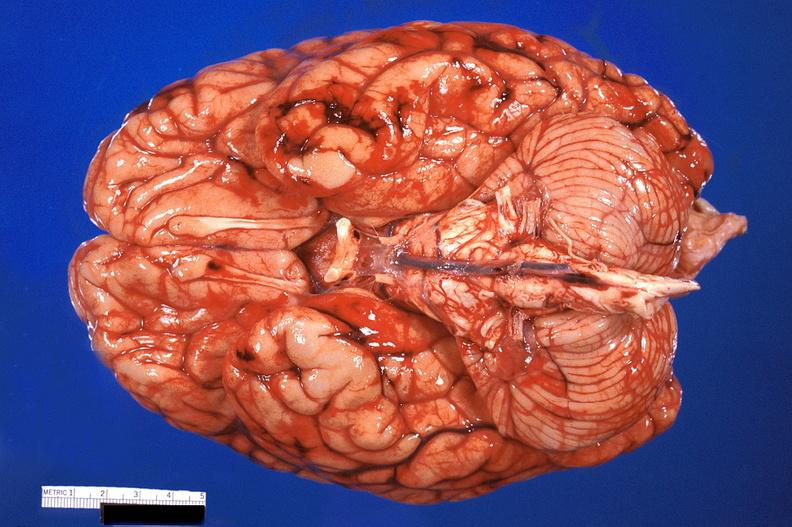does gaucher cell show brain, subarachanoid hemorrhage due to disseminated intravascular coagulation?
Answer the question using a single word or phrase. No 